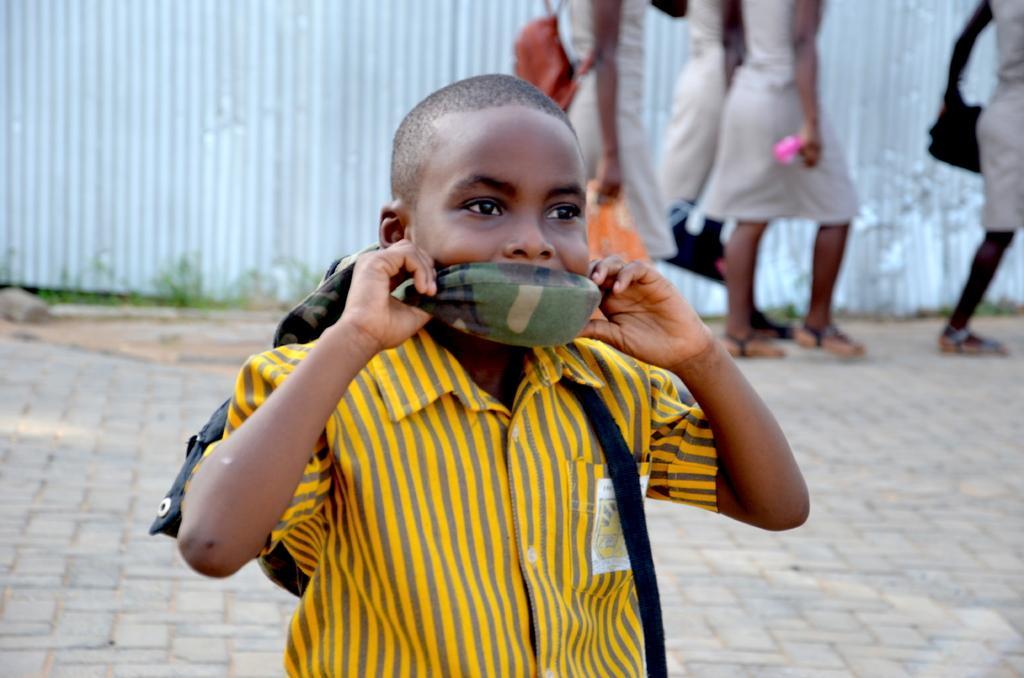How would you summarize this image in a sentence or two? In this picture I can see few people walking and a human wearing a bag and I can see a boy and a cloth to his mouth and I can see metal sheets in the back. 